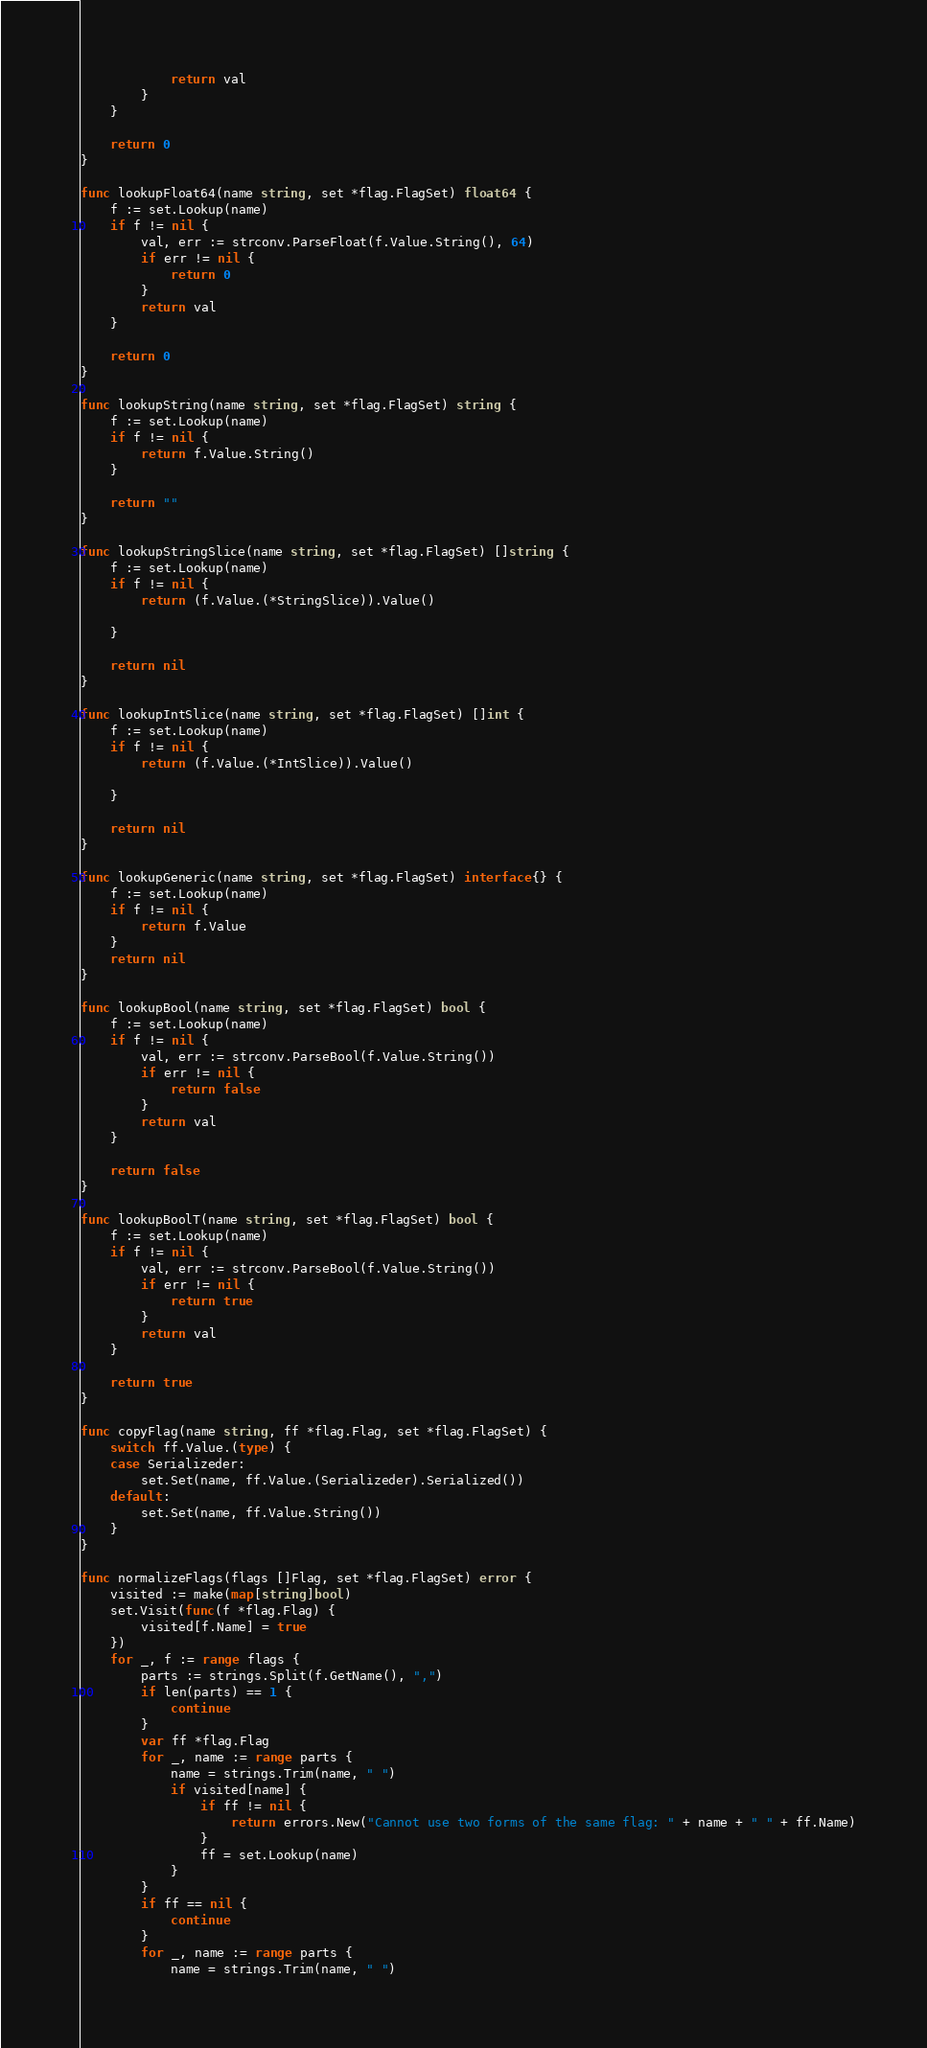<code> <loc_0><loc_0><loc_500><loc_500><_Go_>			return val
		}
	}

	return 0
}

func lookupFloat64(name string, set *flag.FlagSet) float64 {
	f := set.Lookup(name)
	if f != nil {
		val, err := strconv.ParseFloat(f.Value.String(), 64)
		if err != nil {
			return 0
		}
		return val
	}

	return 0
}

func lookupString(name string, set *flag.FlagSet) string {
	f := set.Lookup(name)
	if f != nil {
		return f.Value.String()
	}

	return ""
}

func lookupStringSlice(name string, set *flag.FlagSet) []string {
	f := set.Lookup(name)
	if f != nil {
		return (f.Value.(*StringSlice)).Value()

	}

	return nil
}

func lookupIntSlice(name string, set *flag.FlagSet) []int {
	f := set.Lookup(name)
	if f != nil {
		return (f.Value.(*IntSlice)).Value()

	}

	return nil
}

func lookupGeneric(name string, set *flag.FlagSet) interface{} {
	f := set.Lookup(name)
	if f != nil {
		return f.Value
	}
	return nil
}

func lookupBool(name string, set *flag.FlagSet) bool {
	f := set.Lookup(name)
	if f != nil {
		val, err := strconv.ParseBool(f.Value.String())
		if err != nil {
			return false
		}
		return val
	}

	return false
}

func lookupBoolT(name string, set *flag.FlagSet) bool {
	f := set.Lookup(name)
	if f != nil {
		val, err := strconv.ParseBool(f.Value.String())
		if err != nil {
			return true
		}
		return val
	}

	return true
}

func copyFlag(name string, ff *flag.Flag, set *flag.FlagSet) {
	switch ff.Value.(type) {
	case Serializeder:
		set.Set(name, ff.Value.(Serializeder).Serialized())
	default:
		set.Set(name, ff.Value.String())
	}
}

func normalizeFlags(flags []Flag, set *flag.FlagSet) error {
	visited := make(map[string]bool)
	set.Visit(func(f *flag.Flag) {
		visited[f.Name] = true
	})
	for _, f := range flags {
		parts := strings.Split(f.GetName(), ",")
		if len(parts) == 1 {
			continue
		}
		var ff *flag.Flag
		for _, name := range parts {
			name = strings.Trim(name, " ")
			if visited[name] {
				if ff != nil {
					return errors.New("Cannot use two forms of the same flag: " + name + " " + ff.Name)
				}
				ff = set.Lookup(name)
			}
		}
		if ff == nil {
			continue
		}
		for _, name := range parts {
			name = strings.Trim(name, " ")</code> 